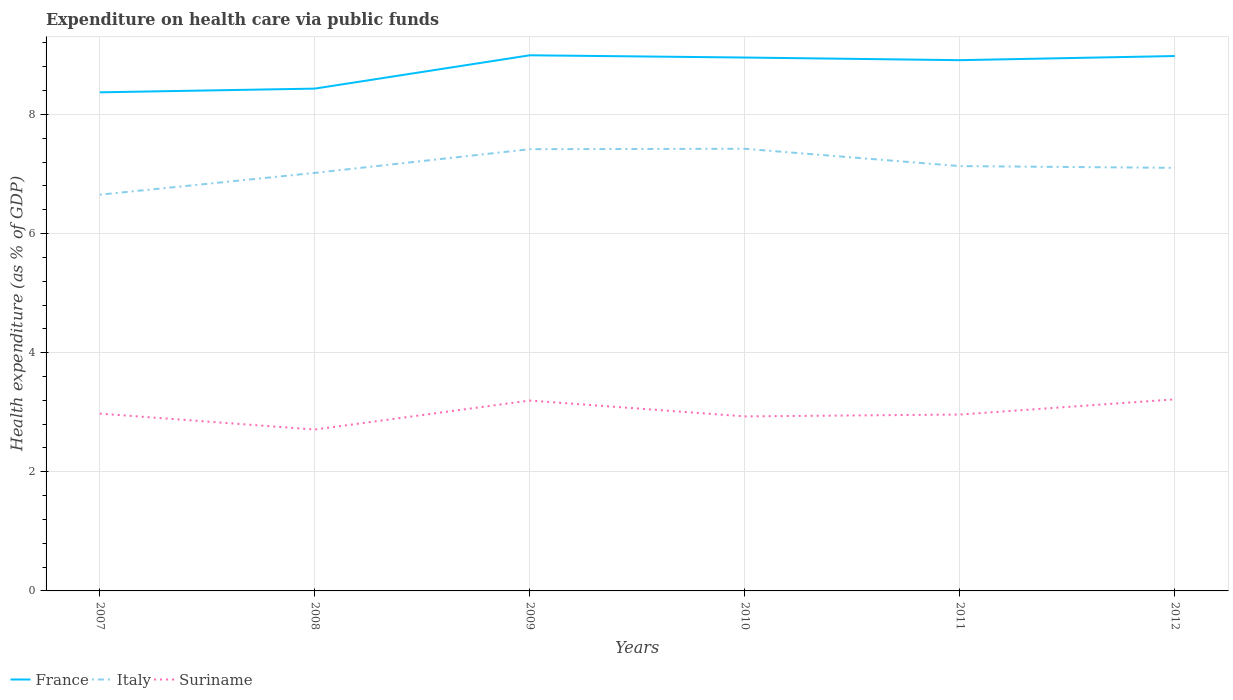Across all years, what is the maximum expenditure made on health care in France?
Give a very brief answer. 8.37. What is the total expenditure made on health care in Italy in the graph?
Offer a terse response. -0.76. What is the difference between the highest and the second highest expenditure made on health care in Suriname?
Offer a very short reply. 0.51. Is the expenditure made on health care in Italy strictly greater than the expenditure made on health care in France over the years?
Give a very brief answer. Yes. How many years are there in the graph?
Provide a short and direct response. 6. Are the values on the major ticks of Y-axis written in scientific E-notation?
Provide a succinct answer. No. Where does the legend appear in the graph?
Provide a short and direct response. Bottom left. How are the legend labels stacked?
Keep it short and to the point. Horizontal. What is the title of the graph?
Make the answer very short. Expenditure on health care via public funds. Does "Bahamas" appear as one of the legend labels in the graph?
Make the answer very short. No. What is the label or title of the Y-axis?
Provide a succinct answer. Health expenditure (as % of GDP). What is the Health expenditure (as % of GDP) of France in 2007?
Your answer should be compact. 8.37. What is the Health expenditure (as % of GDP) in Italy in 2007?
Provide a succinct answer. 6.65. What is the Health expenditure (as % of GDP) of Suriname in 2007?
Ensure brevity in your answer.  2.98. What is the Health expenditure (as % of GDP) of France in 2008?
Provide a short and direct response. 8.43. What is the Health expenditure (as % of GDP) in Italy in 2008?
Your answer should be compact. 7.02. What is the Health expenditure (as % of GDP) in Suriname in 2008?
Your answer should be very brief. 2.71. What is the Health expenditure (as % of GDP) in France in 2009?
Offer a terse response. 8.99. What is the Health expenditure (as % of GDP) of Italy in 2009?
Keep it short and to the point. 7.42. What is the Health expenditure (as % of GDP) in Suriname in 2009?
Give a very brief answer. 3.2. What is the Health expenditure (as % of GDP) of France in 2010?
Give a very brief answer. 8.96. What is the Health expenditure (as % of GDP) in Italy in 2010?
Provide a succinct answer. 7.42. What is the Health expenditure (as % of GDP) of Suriname in 2010?
Ensure brevity in your answer.  2.93. What is the Health expenditure (as % of GDP) of France in 2011?
Your answer should be very brief. 8.91. What is the Health expenditure (as % of GDP) of Italy in 2011?
Keep it short and to the point. 7.13. What is the Health expenditure (as % of GDP) of Suriname in 2011?
Provide a short and direct response. 2.96. What is the Health expenditure (as % of GDP) in France in 2012?
Ensure brevity in your answer.  8.98. What is the Health expenditure (as % of GDP) of Italy in 2012?
Provide a short and direct response. 7.1. What is the Health expenditure (as % of GDP) of Suriname in 2012?
Keep it short and to the point. 3.22. Across all years, what is the maximum Health expenditure (as % of GDP) of France?
Make the answer very short. 8.99. Across all years, what is the maximum Health expenditure (as % of GDP) of Italy?
Your response must be concise. 7.42. Across all years, what is the maximum Health expenditure (as % of GDP) of Suriname?
Ensure brevity in your answer.  3.22. Across all years, what is the minimum Health expenditure (as % of GDP) of France?
Offer a very short reply. 8.37. Across all years, what is the minimum Health expenditure (as % of GDP) in Italy?
Your answer should be compact. 6.65. Across all years, what is the minimum Health expenditure (as % of GDP) in Suriname?
Ensure brevity in your answer.  2.71. What is the total Health expenditure (as % of GDP) in France in the graph?
Offer a terse response. 52.65. What is the total Health expenditure (as % of GDP) in Italy in the graph?
Make the answer very short. 42.75. What is the total Health expenditure (as % of GDP) of Suriname in the graph?
Give a very brief answer. 17.99. What is the difference between the Health expenditure (as % of GDP) in France in 2007 and that in 2008?
Provide a short and direct response. -0.06. What is the difference between the Health expenditure (as % of GDP) in Italy in 2007 and that in 2008?
Make the answer very short. -0.37. What is the difference between the Health expenditure (as % of GDP) in Suriname in 2007 and that in 2008?
Give a very brief answer. 0.27. What is the difference between the Health expenditure (as % of GDP) in France in 2007 and that in 2009?
Offer a very short reply. -0.62. What is the difference between the Health expenditure (as % of GDP) of Italy in 2007 and that in 2009?
Provide a short and direct response. -0.76. What is the difference between the Health expenditure (as % of GDP) in Suriname in 2007 and that in 2009?
Make the answer very short. -0.22. What is the difference between the Health expenditure (as % of GDP) in France in 2007 and that in 2010?
Your response must be concise. -0.58. What is the difference between the Health expenditure (as % of GDP) of Italy in 2007 and that in 2010?
Make the answer very short. -0.77. What is the difference between the Health expenditure (as % of GDP) of Suriname in 2007 and that in 2010?
Ensure brevity in your answer.  0.05. What is the difference between the Health expenditure (as % of GDP) of France in 2007 and that in 2011?
Your response must be concise. -0.54. What is the difference between the Health expenditure (as % of GDP) of Italy in 2007 and that in 2011?
Your answer should be very brief. -0.48. What is the difference between the Health expenditure (as % of GDP) in Suriname in 2007 and that in 2011?
Your response must be concise. 0.02. What is the difference between the Health expenditure (as % of GDP) of France in 2007 and that in 2012?
Give a very brief answer. -0.61. What is the difference between the Health expenditure (as % of GDP) of Italy in 2007 and that in 2012?
Ensure brevity in your answer.  -0.45. What is the difference between the Health expenditure (as % of GDP) of Suriname in 2007 and that in 2012?
Provide a succinct answer. -0.24. What is the difference between the Health expenditure (as % of GDP) in France in 2008 and that in 2009?
Provide a short and direct response. -0.56. What is the difference between the Health expenditure (as % of GDP) of Italy in 2008 and that in 2009?
Give a very brief answer. -0.4. What is the difference between the Health expenditure (as % of GDP) of Suriname in 2008 and that in 2009?
Your answer should be compact. -0.49. What is the difference between the Health expenditure (as % of GDP) in France in 2008 and that in 2010?
Your answer should be very brief. -0.52. What is the difference between the Health expenditure (as % of GDP) of Italy in 2008 and that in 2010?
Ensure brevity in your answer.  -0.41. What is the difference between the Health expenditure (as % of GDP) in Suriname in 2008 and that in 2010?
Ensure brevity in your answer.  -0.22. What is the difference between the Health expenditure (as % of GDP) of France in 2008 and that in 2011?
Keep it short and to the point. -0.48. What is the difference between the Health expenditure (as % of GDP) of Italy in 2008 and that in 2011?
Make the answer very short. -0.11. What is the difference between the Health expenditure (as % of GDP) in Suriname in 2008 and that in 2011?
Your answer should be compact. -0.25. What is the difference between the Health expenditure (as % of GDP) in France in 2008 and that in 2012?
Your answer should be very brief. -0.55. What is the difference between the Health expenditure (as % of GDP) in Italy in 2008 and that in 2012?
Offer a terse response. -0.08. What is the difference between the Health expenditure (as % of GDP) in Suriname in 2008 and that in 2012?
Your answer should be compact. -0.51. What is the difference between the Health expenditure (as % of GDP) of France in 2009 and that in 2010?
Ensure brevity in your answer.  0.04. What is the difference between the Health expenditure (as % of GDP) in Italy in 2009 and that in 2010?
Provide a short and direct response. -0.01. What is the difference between the Health expenditure (as % of GDP) in Suriname in 2009 and that in 2010?
Give a very brief answer. 0.27. What is the difference between the Health expenditure (as % of GDP) of France in 2009 and that in 2011?
Your response must be concise. 0.08. What is the difference between the Health expenditure (as % of GDP) of Italy in 2009 and that in 2011?
Your answer should be compact. 0.28. What is the difference between the Health expenditure (as % of GDP) of Suriname in 2009 and that in 2011?
Your answer should be compact. 0.23. What is the difference between the Health expenditure (as % of GDP) of France in 2009 and that in 2012?
Provide a short and direct response. 0.01. What is the difference between the Health expenditure (as % of GDP) in Italy in 2009 and that in 2012?
Offer a very short reply. 0.31. What is the difference between the Health expenditure (as % of GDP) in Suriname in 2009 and that in 2012?
Keep it short and to the point. -0.02. What is the difference between the Health expenditure (as % of GDP) of France in 2010 and that in 2011?
Your answer should be very brief. 0.04. What is the difference between the Health expenditure (as % of GDP) in Italy in 2010 and that in 2011?
Your answer should be very brief. 0.29. What is the difference between the Health expenditure (as % of GDP) of Suriname in 2010 and that in 2011?
Provide a short and direct response. -0.03. What is the difference between the Health expenditure (as % of GDP) in France in 2010 and that in 2012?
Keep it short and to the point. -0.03. What is the difference between the Health expenditure (as % of GDP) in Italy in 2010 and that in 2012?
Keep it short and to the point. 0.32. What is the difference between the Health expenditure (as % of GDP) of Suriname in 2010 and that in 2012?
Your response must be concise. -0.29. What is the difference between the Health expenditure (as % of GDP) in France in 2011 and that in 2012?
Provide a short and direct response. -0.07. What is the difference between the Health expenditure (as % of GDP) in Italy in 2011 and that in 2012?
Your response must be concise. 0.03. What is the difference between the Health expenditure (as % of GDP) of Suriname in 2011 and that in 2012?
Provide a short and direct response. -0.25. What is the difference between the Health expenditure (as % of GDP) of France in 2007 and the Health expenditure (as % of GDP) of Italy in 2008?
Keep it short and to the point. 1.35. What is the difference between the Health expenditure (as % of GDP) of France in 2007 and the Health expenditure (as % of GDP) of Suriname in 2008?
Make the answer very short. 5.66. What is the difference between the Health expenditure (as % of GDP) of Italy in 2007 and the Health expenditure (as % of GDP) of Suriname in 2008?
Provide a succinct answer. 3.94. What is the difference between the Health expenditure (as % of GDP) of France in 2007 and the Health expenditure (as % of GDP) of Italy in 2009?
Make the answer very short. 0.95. What is the difference between the Health expenditure (as % of GDP) of France in 2007 and the Health expenditure (as % of GDP) of Suriname in 2009?
Provide a short and direct response. 5.18. What is the difference between the Health expenditure (as % of GDP) of Italy in 2007 and the Health expenditure (as % of GDP) of Suriname in 2009?
Your answer should be compact. 3.46. What is the difference between the Health expenditure (as % of GDP) of France in 2007 and the Health expenditure (as % of GDP) of Italy in 2010?
Offer a very short reply. 0.95. What is the difference between the Health expenditure (as % of GDP) of France in 2007 and the Health expenditure (as % of GDP) of Suriname in 2010?
Make the answer very short. 5.44. What is the difference between the Health expenditure (as % of GDP) of Italy in 2007 and the Health expenditure (as % of GDP) of Suriname in 2010?
Offer a very short reply. 3.72. What is the difference between the Health expenditure (as % of GDP) in France in 2007 and the Health expenditure (as % of GDP) in Italy in 2011?
Ensure brevity in your answer.  1.24. What is the difference between the Health expenditure (as % of GDP) in France in 2007 and the Health expenditure (as % of GDP) in Suriname in 2011?
Keep it short and to the point. 5.41. What is the difference between the Health expenditure (as % of GDP) of Italy in 2007 and the Health expenditure (as % of GDP) of Suriname in 2011?
Offer a very short reply. 3.69. What is the difference between the Health expenditure (as % of GDP) in France in 2007 and the Health expenditure (as % of GDP) in Italy in 2012?
Your response must be concise. 1.27. What is the difference between the Health expenditure (as % of GDP) of France in 2007 and the Health expenditure (as % of GDP) of Suriname in 2012?
Make the answer very short. 5.16. What is the difference between the Health expenditure (as % of GDP) in Italy in 2007 and the Health expenditure (as % of GDP) in Suriname in 2012?
Provide a short and direct response. 3.44. What is the difference between the Health expenditure (as % of GDP) of France in 2008 and the Health expenditure (as % of GDP) of Italy in 2009?
Provide a short and direct response. 1.02. What is the difference between the Health expenditure (as % of GDP) of France in 2008 and the Health expenditure (as % of GDP) of Suriname in 2009?
Your answer should be very brief. 5.24. What is the difference between the Health expenditure (as % of GDP) of Italy in 2008 and the Health expenditure (as % of GDP) of Suriname in 2009?
Make the answer very short. 3.82. What is the difference between the Health expenditure (as % of GDP) in France in 2008 and the Health expenditure (as % of GDP) in Italy in 2010?
Provide a succinct answer. 1.01. What is the difference between the Health expenditure (as % of GDP) of France in 2008 and the Health expenditure (as % of GDP) of Suriname in 2010?
Your answer should be very brief. 5.5. What is the difference between the Health expenditure (as % of GDP) in Italy in 2008 and the Health expenditure (as % of GDP) in Suriname in 2010?
Keep it short and to the point. 4.09. What is the difference between the Health expenditure (as % of GDP) in France in 2008 and the Health expenditure (as % of GDP) in Italy in 2011?
Ensure brevity in your answer.  1.3. What is the difference between the Health expenditure (as % of GDP) of France in 2008 and the Health expenditure (as % of GDP) of Suriname in 2011?
Your answer should be very brief. 5.47. What is the difference between the Health expenditure (as % of GDP) of Italy in 2008 and the Health expenditure (as % of GDP) of Suriname in 2011?
Your answer should be very brief. 4.06. What is the difference between the Health expenditure (as % of GDP) in France in 2008 and the Health expenditure (as % of GDP) in Italy in 2012?
Offer a very short reply. 1.33. What is the difference between the Health expenditure (as % of GDP) in France in 2008 and the Health expenditure (as % of GDP) in Suriname in 2012?
Offer a terse response. 5.22. What is the difference between the Health expenditure (as % of GDP) in Italy in 2008 and the Health expenditure (as % of GDP) in Suriname in 2012?
Your answer should be very brief. 3.8. What is the difference between the Health expenditure (as % of GDP) in France in 2009 and the Health expenditure (as % of GDP) in Italy in 2010?
Your answer should be very brief. 1.57. What is the difference between the Health expenditure (as % of GDP) of France in 2009 and the Health expenditure (as % of GDP) of Suriname in 2010?
Give a very brief answer. 6.06. What is the difference between the Health expenditure (as % of GDP) of Italy in 2009 and the Health expenditure (as % of GDP) of Suriname in 2010?
Provide a succinct answer. 4.49. What is the difference between the Health expenditure (as % of GDP) of France in 2009 and the Health expenditure (as % of GDP) of Italy in 2011?
Make the answer very short. 1.86. What is the difference between the Health expenditure (as % of GDP) in France in 2009 and the Health expenditure (as % of GDP) in Suriname in 2011?
Your answer should be compact. 6.03. What is the difference between the Health expenditure (as % of GDP) of Italy in 2009 and the Health expenditure (as % of GDP) of Suriname in 2011?
Provide a short and direct response. 4.46. What is the difference between the Health expenditure (as % of GDP) in France in 2009 and the Health expenditure (as % of GDP) in Italy in 2012?
Make the answer very short. 1.89. What is the difference between the Health expenditure (as % of GDP) of France in 2009 and the Health expenditure (as % of GDP) of Suriname in 2012?
Your answer should be very brief. 5.78. What is the difference between the Health expenditure (as % of GDP) of Italy in 2009 and the Health expenditure (as % of GDP) of Suriname in 2012?
Your response must be concise. 4.2. What is the difference between the Health expenditure (as % of GDP) in France in 2010 and the Health expenditure (as % of GDP) in Italy in 2011?
Keep it short and to the point. 1.82. What is the difference between the Health expenditure (as % of GDP) of France in 2010 and the Health expenditure (as % of GDP) of Suriname in 2011?
Make the answer very short. 5.99. What is the difference between the Health expenditure (as % of GDP) of Italy in 2010 and the Health expenditure (as % of GDP) of Suriname in 2011?
Your answer should be compact. 4.46. What is the difference between the Health expenditure (as % of GDP) of France in 2010 and the Health expenditure (as % of GDP) of Italy in 2012?
Provide a short and direct response. 1.85. What is the difference between the Health expenditure (as % of GDP) of France in 2010 and the Health expenditure (as % of GDP) of Suriname in 2012?
Ensure brevity in your answer.  5.74. What is the difference between the Health expenditure (as % of GDP) of Italy in 2010 and the Health expenditure (as % of GDP) of Suriname in 2012?
Your response must be concise. 4.21. What is the difference between the Health expenditure (as % of GDP) of France in 2011 and the Health expenditure (as % of GDP) of Italy in 2012?
Your answer should be very brief. 1.81. What is the difference between the Health expenditure (as % of GDP) in France in 2011 and the Health expenditure (as % of GDP) in Suriname in 2012?
Offer a terse response. 5.7. What is the difference between the Health expenditure (as % of GDP) of Italy in 2011 and the Health expenditure (as % of GDP) of Suriname in 2012?
Give a very brief answer. 3.92. What is the average Health expenditure (as % of GDP) of France per year?
Your answer should be very brief. 8.77. What is the average Health expenditure (as % of GDP) of Italy per year?
Your response must be concise. 7.12. What is the average Health expenditure (as % of GDP) in Suriname per year?
Offer a very short reply. 3. In the year 2007, what is the difference between the Health expenditure (as % of GDP) in France and Health expenditure (as % of GDP) in Italy?
Keep it short and to the point. 1.72. In the year 2007, what is the difference between the Health expenditure (as % of GDP) of France and Health expenditure (as % of GDP) of Suriname?
Provide a short and direct response. 5.39. In the year 2007, what is the difference between the Health expenditure (as % of GDP) in Italy and Health expenditure (as % of GDP) in Suriname?
Make the answer very short. 3.68. In the year 2008, what is the difference between the Health expenditure (as % of GDP) of France and Health expenditure (as % of GDP) of Italy?
Your answer should be compact. 1.42. In the year 2008, what is the difference between the Health expenditure (as % of GDP) in France and Health expenditure (as % of GDP) in Suriname?
Your response must be concise. 5.72. In the year 2008, what is the difference between the Health expenditure (as % of GDP) of Italy and Health expenditure (as % of GDP) of Suriname?
Provide a short and direct response. 4.31. In the year 2009, what is the difference between the Health expenditure (as % of GDP) of France and Health expenditure (as % of GDP) of Italy?
Offer a very short reply. 1.58. In the year 2009, what is the difference between the Health expenditure (as % of GDP) of France and Health expenditure (as % of GDP) of Suriname?
Give a very brief answer. 5.8. In the year 2009, what is the difference between the Health expenditure (as % of GDP) of Italy and Health expenditure (as % of GDP) of Suriname?
Ensure brevity in your answer.  4.22. In the year 2010, what is the difference between the Health expenditure (as % of GDP) of France and Health expenditure (as % of GDP) of Italy?
Keep it short and to the point. 1.53. In the year 2010, what is the difference between the Health expenditure (as % of GDP) of France and Health expenditure (as % of GDP) of Suriname?
Give a very brief answer. 6.03. In the year 2010, what is the difference between the Health expenditure (as % of GDP) in Italy and Health expenditure (as % of GDP) in Suriname?
Make the answer very short. 4.49. In the year 2011, what is the difference between the Health expenditure (as % of GDP) in France and Health expenditure (as % of GDP) in Italy?
Your answer should be compact. 1.78. In the year 2011, what is the difference between the Health expenditure (as % of GDP) in France and Health expenditure (as % of GDP) in Suriname?
Your answer should be compact. 5.95. In the year 2011, what is the difference between the Health expenditure (as % of GDP) of Italy and Health expenditure (as % of GDP) of Suriname?
Provide a succinct answer. 4.17. In the year 2012, what is the difference between the Health expenditure (as % of GDP) in France and Health expenditure (as % of GDP) in Italy?
Ensure brevity in your answer.  1.88. In the year 2012, what is the difference between the Health expenditure (as % of GDP) of France and Health expenditure (as % of GDP) of Suriname?
Your response must be concise. 5.76. In the year 2012, what is the difference between the Health expenditure (as % of GDP) of Italy and Health expenditure (as % of GDP) of Suriname?
Your answer should be compact. 3.89. What is the ratio of the Health expenditure (as % of GDP) of Italy in 2007 to that in 2008?
Make the answer very short. 0.95. What is the ratio of the Health expenditure (as % of GDP) of Suriname in 2007 to that in 2008?
Your answer should be compact. 1.1. What is the ratio of the Health expenditure (as % of GDP) of France in 2007 to that in 2009?
Your response must be concise. 0.93. What is the ratio of the Health expenditure (as % of GDP) in Italy in 2007 to that in 2009?
Give a very brief answer. 0.9. What is the ratio of the Health expenditure (as % of GDP) of Suriname in 2007 to that in 2009?
Ensure brevity in your answer.  0.93. What is the ratio of the Health expenditure (as % of GDP) of France in 2007 to that in 2010?
Keep it short and to the point. 0.93. What is the ratio of the Health expenditure (as % of GDP) of Italy in 2007 to that in 2010?
Offer a terse response. 0.9. What is the ratio of the Health expenditure (as % of GDP) in Suriname in 2007 to that in 2010?
Your answer should be very brief. 1.02. What is the ratio of the Health expenditure (as % of GDP) of France in 2007 to that in 2011?
Provide a succinct answer. 0.94. What is the ratio of the Health expenditure (as % of GDP) in Italy in 2007 to that in 2011?
Your answer should be very brief. 0.93. What is the ratio of the Health expenditure (as % of GDP) in Suriname in 2007 to that in 2011?
Offer a terse response. 1.01. What is the ratio of the Health expenditure (as % of GDP) in France in 2007 to that in 2012?
Your response must be concise. 0.93. What is the ratio of the Health expenditure (as % of GDP) in Italy in 2007 to that in 2012?
Your answer should be compact. 0.94. What is the ratio of the Health expenditure (as % of GDP) of Suriname in 2007 to that in 2012?
Provide a short and direct response. 0.93. What is the ratio of the Health expenditure (as % of GDP) of France in 2008 to that in 2009?
Give a very brief answer. 0.94. What is the ratio of the Health expenditure (as % of GDP) in Italy in 2008 to that in 2009?
Keep it short and to the point. 0.95. What is the ratio of the Health expenditure (as % of GDP) in Suriname in 2008 to that in 2009?
Ensure brevity in your answer.  0.85. What is the ratio of the Health expenditure (as % of GDP) in France in 2008 to that in 2010?
Give a very brief answer. 0.94. What is the ratio of the Health expenditure (as % of GDP) in Italy in 2008 to that in 2010?
Your response must be concise. 0.95. What is the ratio of the Health expenditure (as % of GDP) of Suriname in 2008 to that in 2010?
Keep it short and to the point. 0.92. What is the ratio of the Health expenditure (as % of GDP) in France in 2008 to that in 2011?
Offer a very short reply. 0.95. What is the ratio of the Health expenditure (as % of GDP) of Suriname in 2008 to that in 2011?
Keep it short and to the point. 0.91. What is the ratio of the Health expenditure (as % of GDP) in France in 2008 to that in 2012?
Your answer should be very brief. 0.94. What is the ratio of the Health expenditure (as % of GDP) of Suriname in 2008 to that in 2012?
Ensure brevity in your answer.  0.84. What is the ratio of the Health expenditure (as % of GDP) of Italy in 2009 to that in 2010?
Offer a very short reply. 1. What is the ratio of the Health expenditure (as % of GDP) in Suriname in 2009 to that in 2010?
Make the answer very short. 1.09. What is the ratio of the Health expenditure (as % of GDP) in France in 2009 to that in 2011?
Make the answer very short. 1.01. What is the ratio of the Health expenditure (as % of GDP) of Italy in 2009 to that in 2011?
Offer a terse response. 1.04. What is the ratio of the Health expenditure (as % of GDP) of Suriname in 2009 to that in 2011?
Provide a succinct answer. 1.08. What is the ratio of the Health expenditure (as % of GDP) in Italy in 2009 to that in 2012?
Provide a short and direct response. 1.04. What is the ratio of the Health expenditure (as % of GDP) of Italy in 2010 to that in 2011?
Ensure brevity in your answer.  1.04. What is the ratio of the Health expenditure (as % of GDP) of Suriname in 2010 to that in 2011?
Your answer should be compact. 0.99. What is the ratio of the Health expenditure (as % of GDP) in France in 2010 to that in 2012?
Your answer should be compact. 1. What is the ratio of the Health expenditure (as % of GDP) of Italy in 2010 to that in 2012?
Your answer should be compact. 1.05. What is the ratio of the Health expenditure (as % of GDP) in Suriname in 2010 to that in 2012?
Offer a very short reply. 0.91. What is the ratio of the Health expenditure (as % of GDP) in France in 2011 to that in 2012?
Keep it short and to the point. 0.99. What is the ratio of the Health expenditure (as % of GDP) in Suriname in 2011 to that in 2012?
Offer a very short reply. 0.92. What is the difference between the highest and the second highest Health expenditure (as % of GDP) in France?
Keep it short and to the point. 0.01. What is the difference between the highest and the second highest Health expenditure (as % of GDP) of Italy?
Provide a short and direct response. 0.01. What is the difference between the highest and the second highest Health expenditure (as % of GDP) of Suriname?
Keep it short and to the point. 0.02. What is the difference between the highest and the lowest Health expenditure (as % of GDP) of France?
Provide a succinct answer. 0.62. What is the difference between the highest and the lowest Health expenditure (as % of GDP) of Italy?
Offer a terse response. 0.77. What is the difference between the highest and the lowest Health expenditure (as % of GDP) of Suriname?
Offer a terse response. 0.51. 